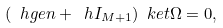Convert formula to latex. <formula><loc_0><loc_0><loc_500><loc_500>( \ h g e n + \ h I _ { M + 1 } ) \ k e t { \Omega } = 0 ,</formula> 